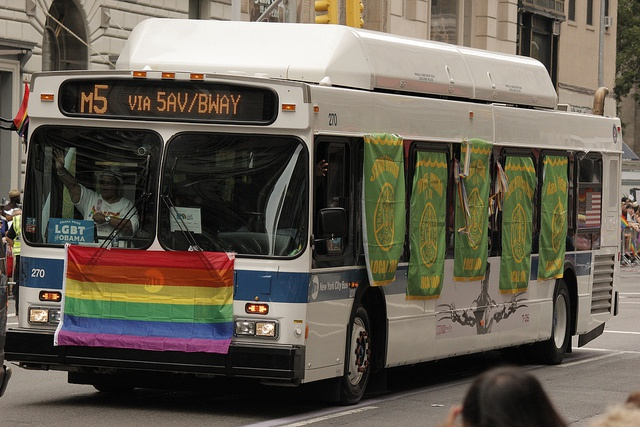Describe the objects in this image and their specific colors. I can see bus in black, darkgray, gray, and darkgreen tones, people in darkgray, black, and gray tones, people in darkgray, black, gray, and darkgreen tones, people in darkgray, black, olive, and khaki tones, and traffic light in darkgray, tan, olive, and orange tones in this image. 